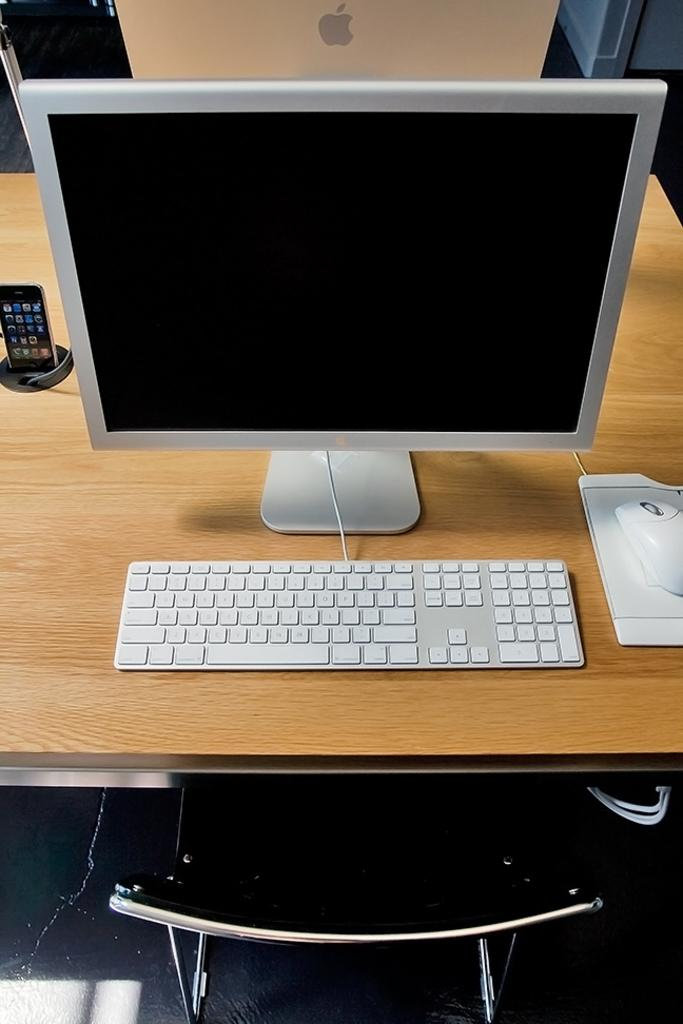What electronic device is visible in the image? There is a computer in the image. What input device is used with the computer? There is a keyboard and a mouse in the image. Where are the computer, keyboard, and mouse located? They are on a table in the image. What piece of furniture is in front of the table? There is a chair in front of the table. What other electronic device is present in the image? There is a mobile in the image. What type of sea creature can be seen crawling on the keyboard in the image? There are no sea creatures present in the image, and the keyboard is not depicted as having any living organisms on it. 